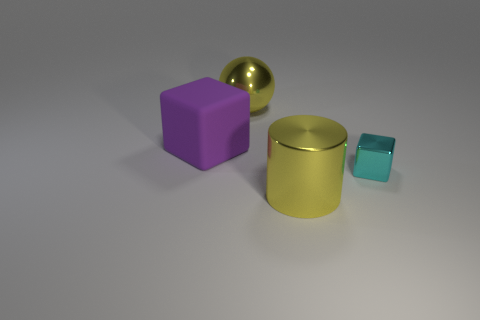What is the color of the sphere that is made of the same material as the large cylinder?
Make the answer very short. Yellow. What number of tiny blue balls have the same material as the tiny cyan block?
Your response must be concise. 0. Does the tiny cyan thing have the same material as the object that is in front of the metallic block?
Offer a very short reply. Yes. How many objects are big metallic things that are in front of the tiny thing or big cylinders?
Ensure brevity in your answer.  1. What size is the cube that is to the left of the yellow object that is on the right side of the big metal thing that is behind the shiny cylinder?
Your response must be concise. Large. There is a thing that is the same color as the cylinder; what is it made of?
Your answer should be compact. Metal. Is there anything else that is the same shape as the rubber thing?
Keep it short and to the point. Yes. There is a yellow shiny object right of the yellow metal thing behind the big metal cylinder; what size is it?
Keep it short and to the point. Large. What number of tiny things are yellow metal cylinders or blocks?
Keep it short and to the point. 1. Is the number of small purple metal blocks less than the number of tiny cyan metal blocks?
Ensure brevity in your answer.  Yes. 